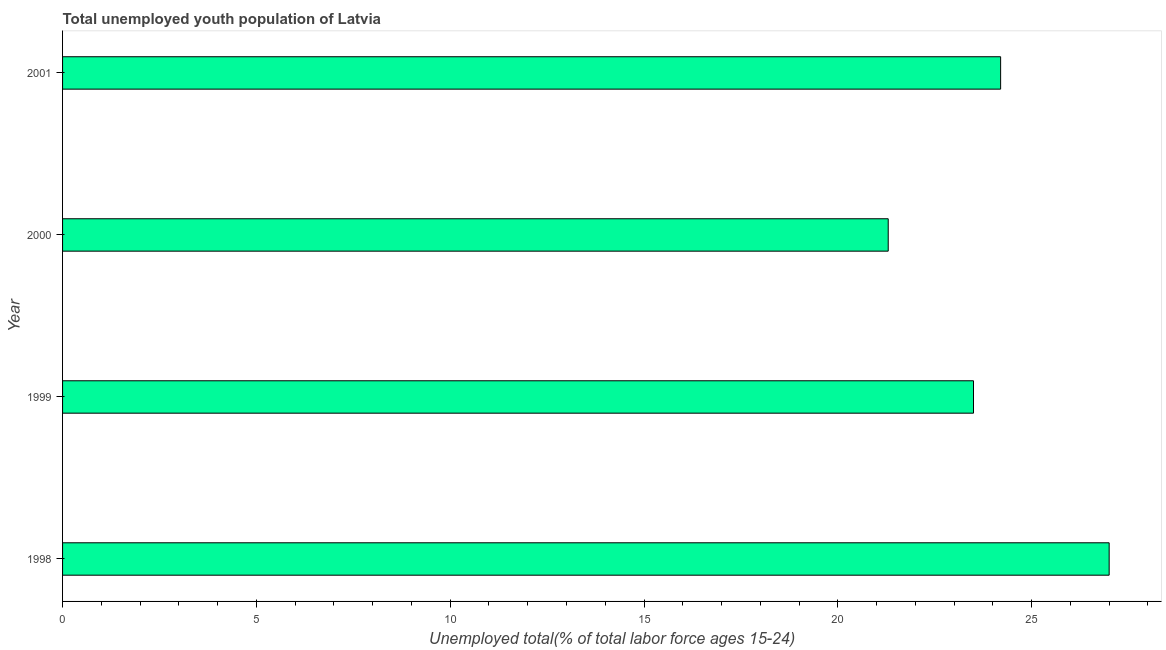Does the graph contain grids?
Ensure brevity in your answer.  No. What is the title of the graph?
Your answer should be very brief. Total unemployed youth population of Latvia. What is the label or title of the X-axis?
Offer a terse response. Unemployed total(% of total labor force ages 15-24). What is the label or title of the Y-axis?
Provide a short and direct response. Year. What is the unemployed youth in 1998?
Make the answer very short. 27. Across all years, what is the maximum unemployed youth?
Provide a short and direct response. 27. Across all years, what is the minimum unemployed youth?
Make the answer very short. 21.3. What is the sum of the unemployed youth?
Offer a very short reply. 96. What is the difference between the unemployed youth in 1999 and 2001?
Make the answer very short. -0.7. What is the average unemployed youth per year?
Ensure brevity in your answer.  24. What is the median unemployed youth?
Your answer should be compact. 23.85. In how many years, is the unemployed youth greater than 16 %?
Ensure brevity in your answer.  4. Do a majority of the years between 1998 and 2001 (inclusive) have unemployed youth greater than 2 %?
Provide a succinct answer. Yes. What is the ratio of the unemployed youth in 1998 to that in 2001?
Your answer should be very brief. 1.12. Is the sum of the unemployed youth in 2000 and 2001 greater than the maximum unemployed youth across all years?
Make the answer very short. Yes. In how many years, is the unemployed youth greater than the average unemployed youth taken over all years?
Make the answer very short. 2. How many bars are there?
Your answer should be compact. 4. Are all the bars in the graph horizontal?
Offer a terse response. Yes. How many years are there in the graph?
Keep it short and to the point. 4. What is the Unemployed total(% of total labor force ages 15-24) of 1998?
Keep it short and to the point. 27. What is the Unemployed total(% of total labor force ages 15-24) of 2000?
Your answer should be very brief. 21.3. What is the Unemployed total(% of total labor force ages 15-24) in 2001?
Provide a short and direct response. 24.2. What is the difference between the Unemployed total(% of total labor force ages 15-24) in 1998 and 1999?
Make the answer very short. 3.5. What is the difference between the Unemployed total(% of total labor force ages 15-24) in 1998 and 2001?
Make the answer very short. 2.8. What is the difference between the Unemployed total(% of total labor force ages 15-24) in 1999 and 2000?
Give a very brief answer. 2.2. What is the ratio of the Unemployed total(% of total labor force ages 15-24) in 1998 to that in 1999?
Keep it short and to the point. 1.15. What is the ratio of the Unemployed total(% of total labor force ages 15-24) in 1998 to that in 2000?
Your answer should be compact. 1.27. What is the ratio of the Unemployed total(% of total labor force ages 15-24) in 1998 to that in 2001?
Provide a succinct answer. 1.12. What is the ratio of the Unemployed total(% of total labor force ages 15-24) in 1999 to that in 2000?
Your answer should be compact. 1.1. 